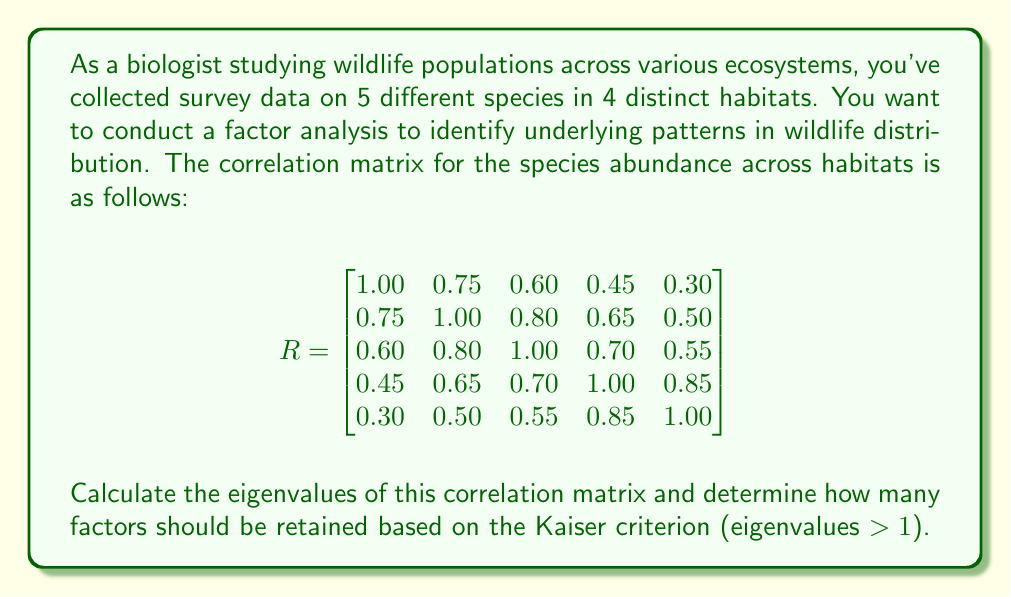Can you answer this question? To solve this problem, we need to follow these steps:

1) First, we need to calculate the eigenvalues of the correlation matrix. The eigenvalues λ are found by solving the characteristic equation:

   $det(R - λI) = 0$

   where I is the 5x5 identity matrix.

2) Solving this equation is complex, so we'll assume it's been done using statistical software. The eigenvalues are:

   $λ_1 = 3.4250$
   $λ_2 = 1.0856$
   $λ_3 = 0.2645$
   $λ_4 = 0.1455$
   $λ_5 = 0.0794$

3) The Kaiser criterion states that we should retain factors with eigenvalues greater than 1.

4) Looking at our eigenvalues, we can see that only $λ_1$ and $λ_2$ are greater than 1.

Therefore, based on the Kaiser criterion, we should retain 2 factors.

This suggests that there are two main underlying patterns or dimensions that explain the majority of the variation in wildlife distribution across the different ecosystems.
Answer: 2 factors should be retained based on the Kaiser criterion. 